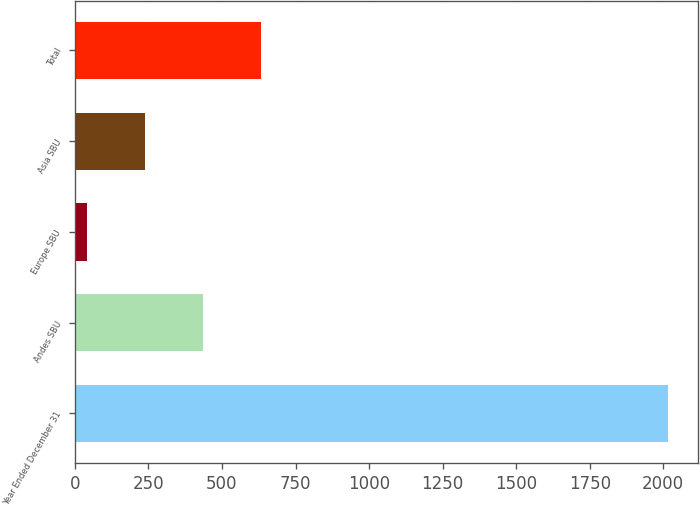<chart> <loc_0><loc_0><loc_500><loc_500><bar_chart><fcel>Year Ended December 31<fcel>Andes SBU<fcel>Europe SBU<fcel>Asia SBU<fcel>Total<nl><fcel>2016<fcel>436<fcel>41<fcel>238.5<fcel>633.5<nl></chart> 